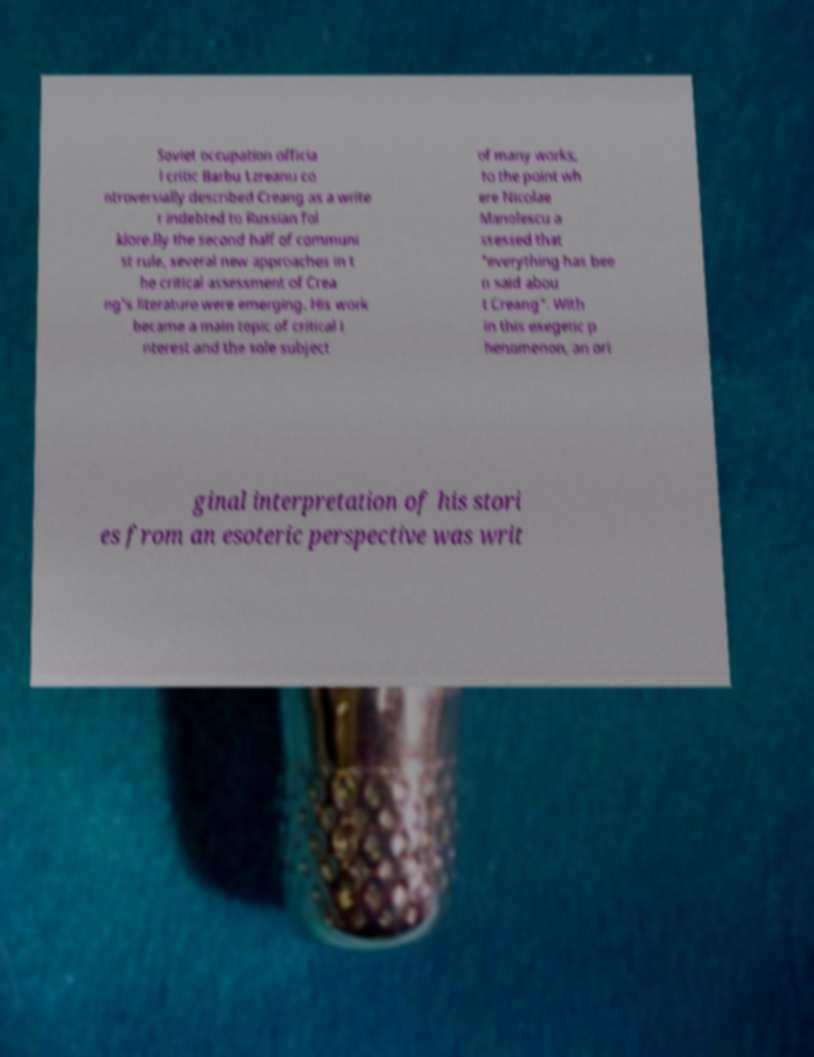I need the written content from this picture converted into text. Can you do that? Soviet occupation officia l critic Barbu Lzreanu co ntroversially described Creang as a write r indebted to Russian fol klore.By the second half of communi st rule, several new approaches in t he critical assessment of Crea ng's literature were emerging. His work became a main topic of critical i nterest and the sole subject of many works, to the point wh ere Nicolae Manolescu a ssessed that "everything has bee n said abou t Creang". With in this exegetic p henomenon, an ori ginal interpretation of his stori es from an esoteric perspective was writ 